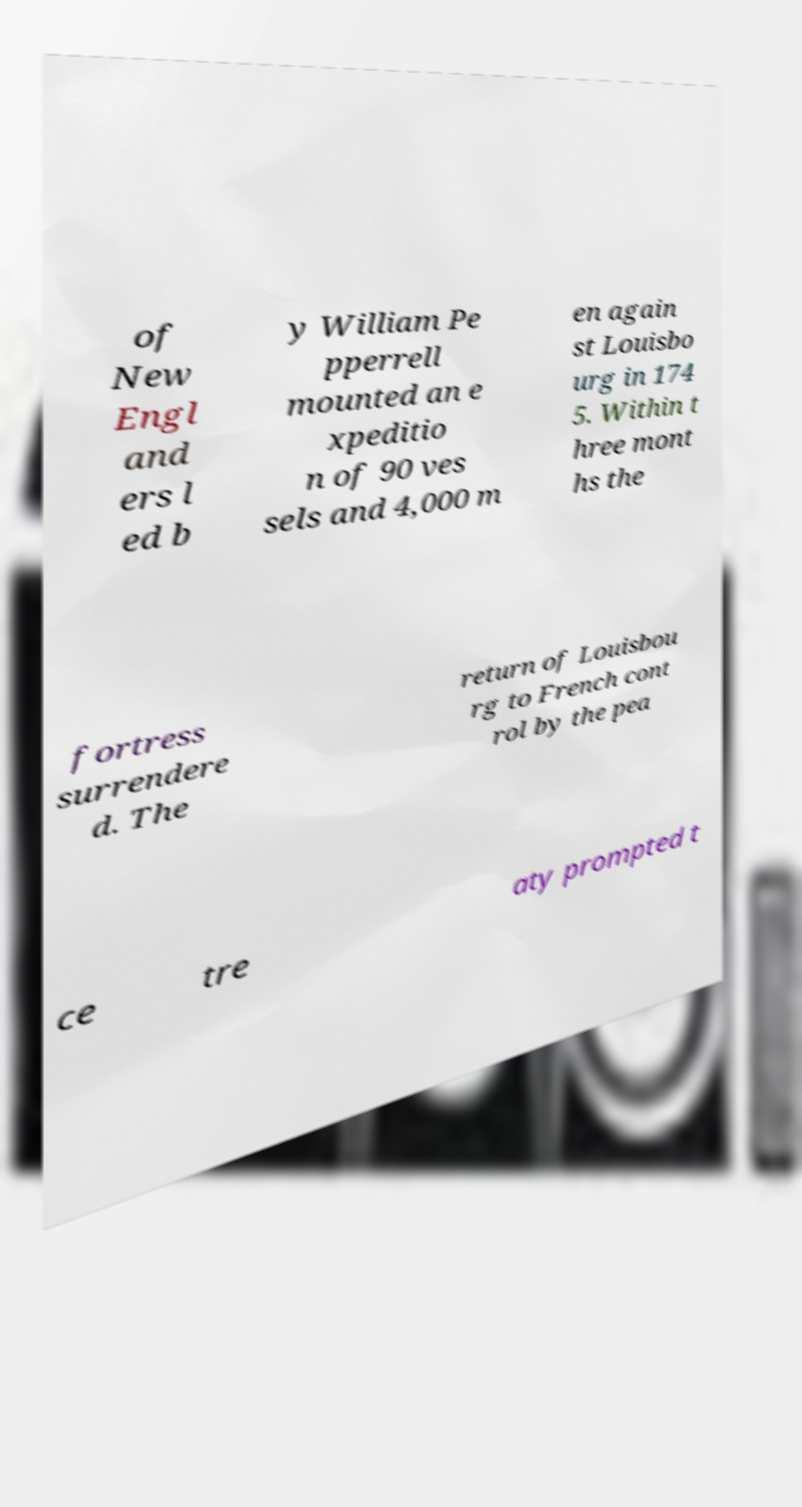Could you assist in decoding the text presented in this image and type it out clearly? of New Engl and ers l ed b y William Pe pperrell mounted an e xpeditio n of 90 ves sels and 4,000 m en again st Louisbo urg in 174 5. Within t hree mont hs the fortress surrendere d. The return of Louisbou rg to French cont rol by the pea ce tre aty prompted t 